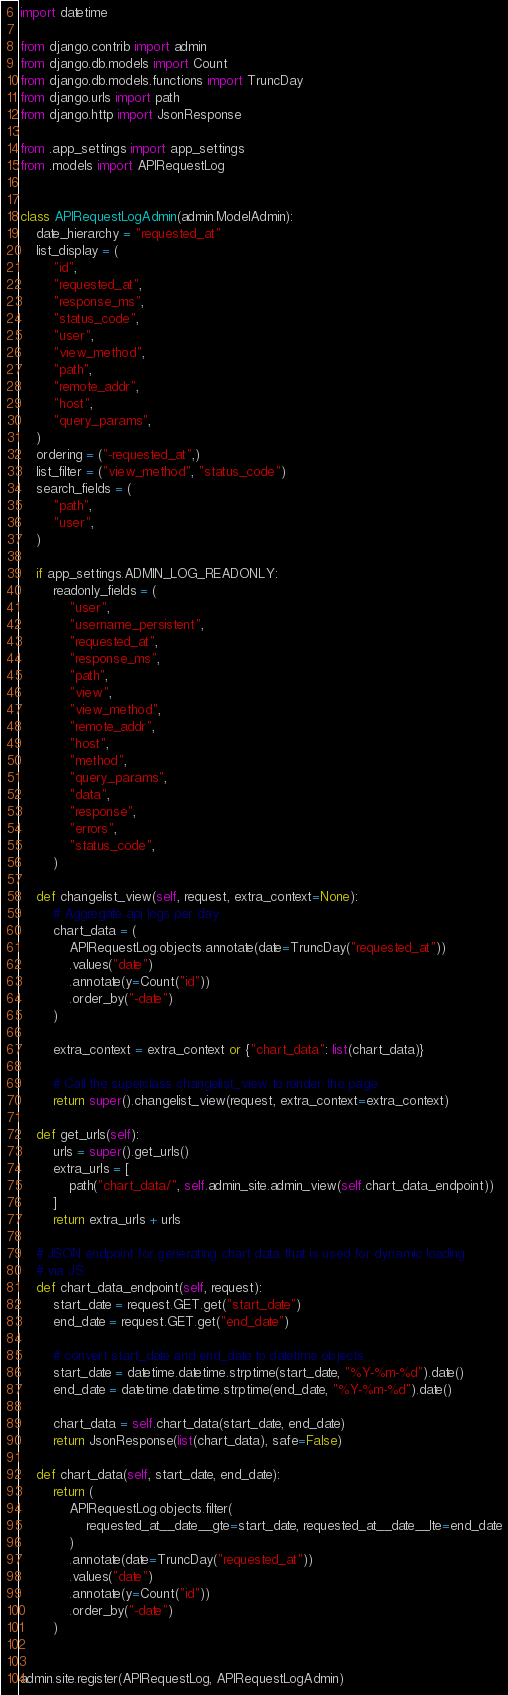Convert code to text. <code><loc_0><loc_0><loc_500><loc_500><_Python_>import datetime

from django.contrib import admin
from django.db.models import Count
from django.db.models.functions import TruncDay
from django.urls import path
from django.http import JsonResponse

from .app_settings import app_settings
from .models import APIRequestLog


class APIRequestLogAdmin(admin.ModelAdmin):
    date_hierarchy = "requested_at"
    list_display = (
        "id",
        "requested_at",
        "response_ms",
        "status_code",
        "user",
        "view_method",
        "path",
        "remote_addr",
        "host",
        "query_params",
    )
    ordering = ("-requested_at",)
    list_filter = ("view_method", "status_code")
    search_fields = (
        "path",
        "user",
    )

    if app_settings.ADMIN_LOG_READONLY:
        readonly_fields = (
            "user",
            "username_persistent",
            "requested_at",
            "response_ms",
            "path",
            "view",
            "view_method",
            "remote_addr",
            "host",
            "method",
            "query_params",
            "data",
            "response",
            "errors",
            "status_code",
        )

    def changelist_view(self, request, extra_context=None):
        # Aggregate api logs per day
        chart_data = (
            APIRequestLog.objects.annotate(date=TruncDay("requested_at"))
            .values("date")
            .annotate(y=Count("id"))
            .order_by("-date")
        )

        extra_context = extra_context or {"chart_data": list(chart_data)}

        # Call the superclass changelist_view to render the page
        return super().changelist_view(request, extra_context=extra_context)

    def get_urls(self):
        urls = super().get_urls()
        extra_urls = [
            path("chart_data/", self.admin_site.admin_view(self.chart_data_endpoint))
        ]
        return extra_urls + urls

    # JSON endpoint for generating chart data that is used for dynamic loading
    # via JS.
    def chart_data_endpoint(self, request):
        start_date = request.GET.get("start_date")
        end_date = request.GET.get("end_date")

        # convert start_date and end_date to datetime objects
        start_date = datetime.datetime.strptime(start_date, "%Y-%m-%d").date()
        end_date = datetime.datetime.strptime(end_date, "%Y-%m-%d").date()

        chart_data = self.chart_data(start_date, end_date)
        return JsonResponse(list(chart_data), safe=False)

    def chart_data(self, start_date, end_date):
        return (
            APIRequestLog.objects.filter(
                requested_at__date__gte=start_date, requested_at__date__lte=end_date
            )
            .annotate(date=TruncDay("requested_at"))
            .values("date")
            .annotate(y=Count("id"))
            .order_by("-date")
        )


admin.site.register(APIRequestLog, APIRequestLogAdmin)
</code> 